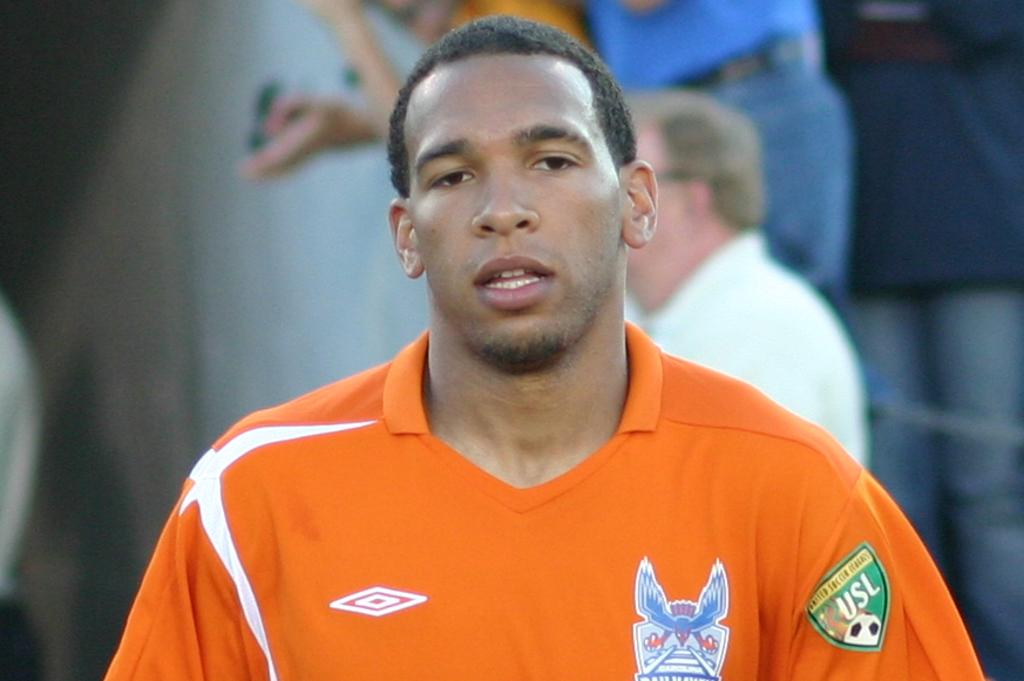<image>
Render a clear and concise summary of the photo. A man is wearing an orange shirt with a badge for the USL on it. 